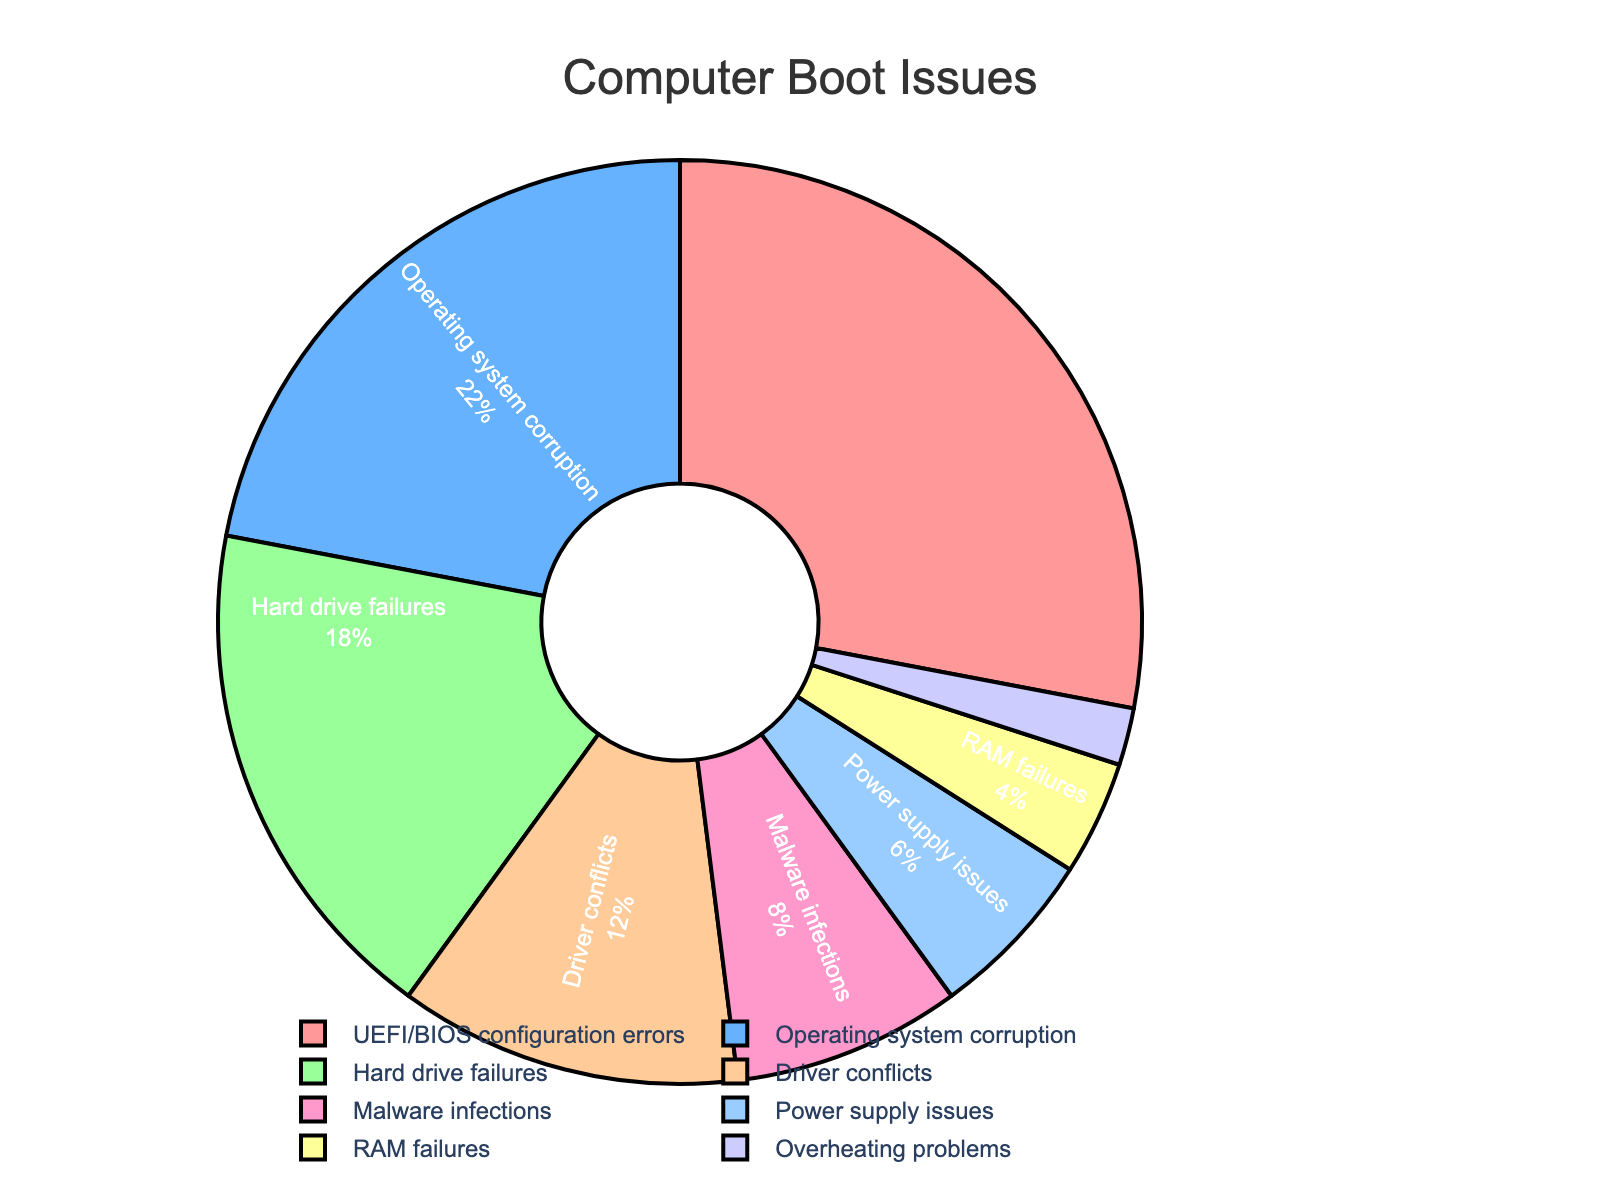How many total types of boot issues are presented in the chart? Count the number of distinct labels in the pie chart, which represents different types of boot issues. There are eight distinct labels represented.
Answer: 8 Which type of boot issue has the highest percentage? Identify the segment with the highest percentage label. The "UEFI/BIOS configuration errors" segment has the highest percentage at 28%.
Answer: UEFI/BIOS configuration errors What is the combined percentage of Operating system corruption and Hard drive failures? Add the percentages of "Operating system corruption" (22%) and "Hard drive failures" (18%) together. 22% + 18% = 40%.
Answer: 40% Which problem has the smallest percentage, and what color is its segment? Look for the segment with the smallest percentage label, which is "Overheating problems" at 2%. The color of this segment is represented by a particular shade in the pie chart, which is purple in this case.
Answer: Overheating problems, purple Are Driver conflicts more common than Malware infections? Compare the percentages of "Driver conflicts" (12%) and "Malware infections" (8%). Since 12% is greater than 8%, Driver conflicts are more common.
Answer: Yes What is the difference in percentage between Power supply issues and RAM failures? Subtract the percentage of "RAM failures" (4%) from the percentage of "Power supply issues" (6%). 6% - 4% = 2%.
Answer: 2% What percentage of users experience software-related issues (comprising UEFI/BIOS configuration errors and Operating system corruption)? Add the percentages of "UEFI/BIOS configuration errors" (28%) and "Operating system corruption" (22%) together. 28% + 22% = 50%.
Answer: 50% Which issue is depicted with a red color, and what is its percentage? Identify the segment colored red and its corresponding percentage label. The red segment represents "UEFI/BIOS configuration errors" with a percentage of 28%.
Answer: UEFI/BIOS configuration errors, 28% Which has a higher percentage: Hardware-related issues (Hard drive failures + Power supply issues + RAM failures) or Driver conflicts? Calculate the sum of percentages for hardware-related issues: Hard drive failures (18%) + Power supply issues (6%) + RAM failures (4%) = 28%. Compare this with "Driver conflicts" (12%). Since 28% is greater than 12%, hardware-related issues have a higher percentage.
Answer: Hardware-related issues What is the percentage of users facing boot issues due to either Driver conflicts or Malware infections? Add the percentages of "Driver conflicts" (12%) and "Malware infections" (8%). 12% + 8% = 20%.
Answer: 20% 